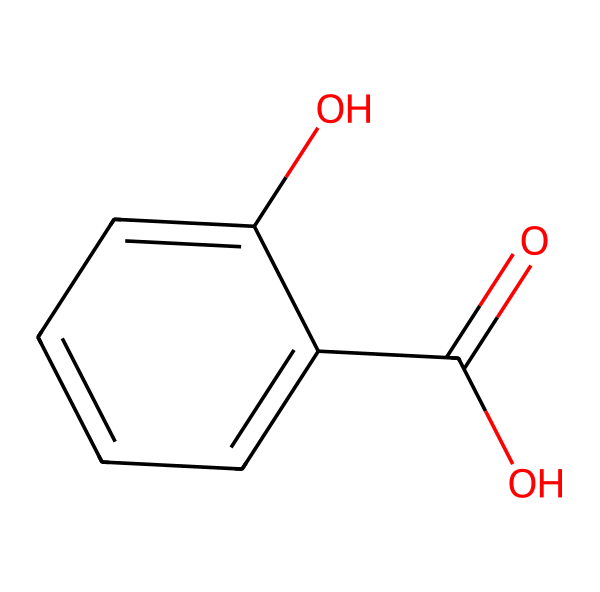What is the molecular formula of salicylic acid? To determine the molecular formula, count the number of each type of atom in the SMILES representation. The structure contains 7 carbon (C) atoms, 6 hydrogen (H) atoms, and 3 oxygen (O) atoms. Thus, the molecular formula is C7H6O3.
Answer: C7H6O3 How many hydroxyl groups are present in salicylic acid? The presence of a hydroxyl group is indicated by the -OH functional group. In the SMILES representation, there is one -OH attached to the aromatic ring and another one in the carboxylic acid (-COOH) group, totaling 2 hydroxyl groups.
Answer: 2 What type of bonding is present in the aromatic ring of salicylic acid? The aromatic ring features resonance and delocalized electrons, where the carbon-carbon bonds alternate between single and double bonds. This characteristic bonding allows for stability in aromatic compounds like salicylic acid.
Answer: resonance What functional groups are present in salicylic acid? The molecule contains two functional groups: the carboxylic acid (-COOH) and the phenolic hydroxyl (-OH) group. These functional groups are key to the chemical's properties and reactivity.
Answer: carboxylic acid and phenolic hydroxyl How many rings are present in the molecular structure of salicylic acid? Analyzing the molecular structure, salicylic acid contains only one ring, which is the benzene ring formed by the six carbon atoms in the aromatic portion of the molecule.
Answer: 1 What is the significance of the carboxylic acid group in salicylic acid? The carboxylic acid group is crucial for the molecule's role as a precursor in the synthesis of aspirin, providing anti-inflammatory and analgesic properties. This functional group plays a vital role in salicylic acid's biological activity.
Answer: anti-inflammatory and analgesic What property does the presence of the hydroxyl group impart on salicylic acid? The hydroxyl groups make salicylic acid polar, influencing its solubility in water and its ability to participate in hydrogen bonding, which enhances its effectiveness in biological systems.
Answer: polar 